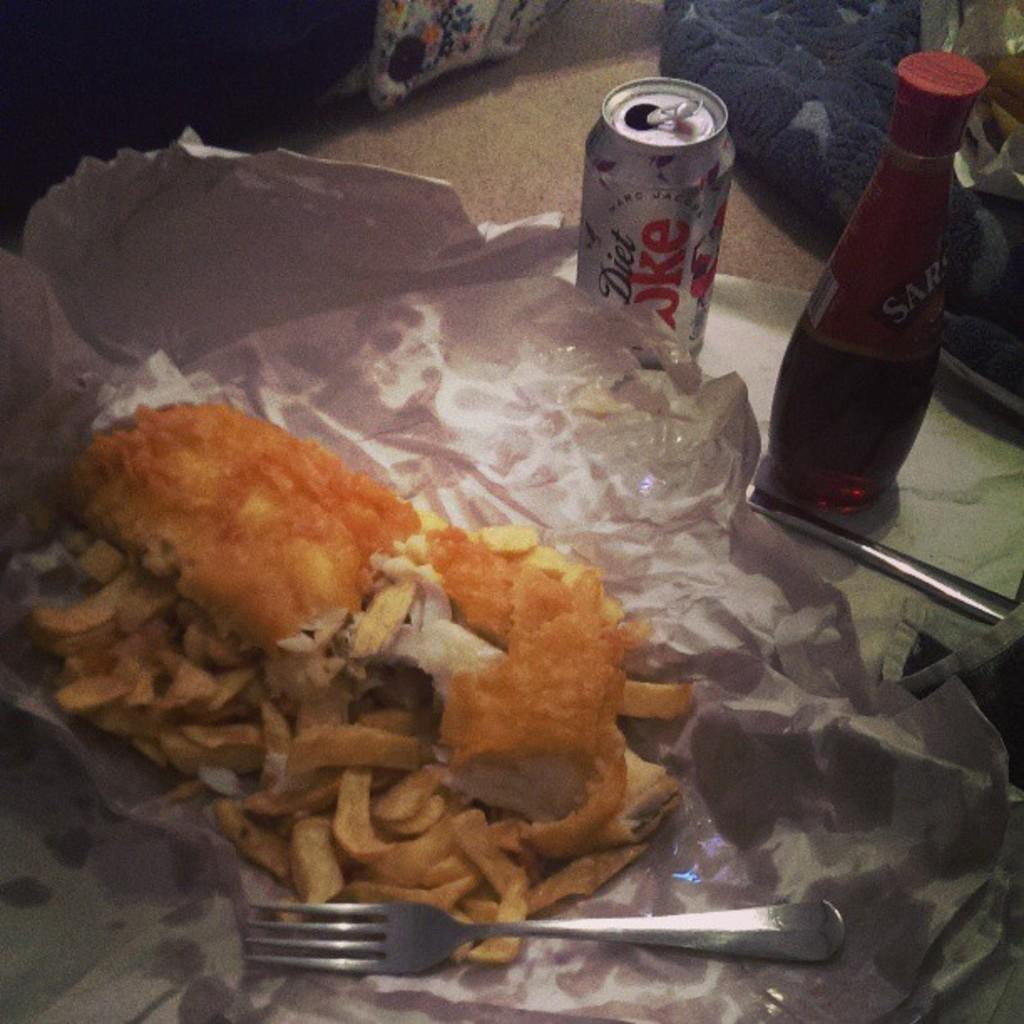Provide a one-sentence caption for the provided image. A can of diet coke sits next to food. 